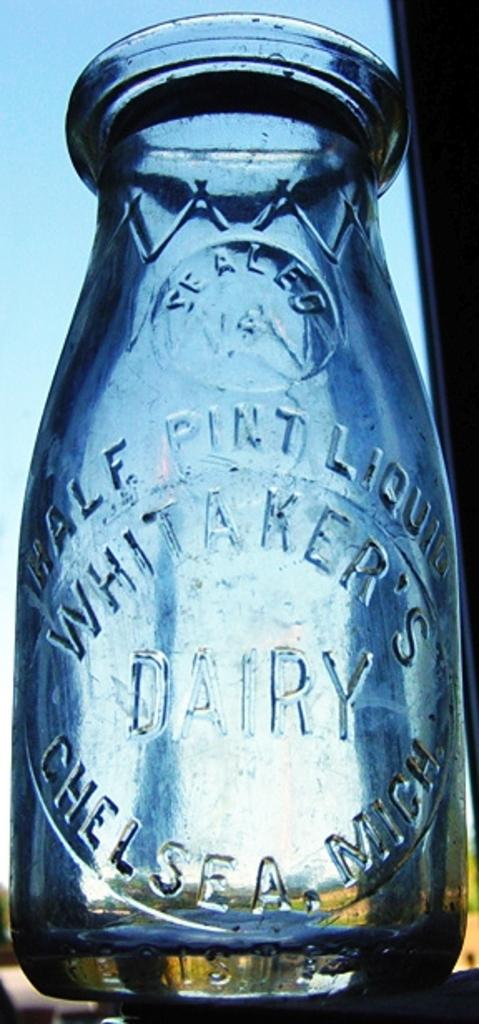<image>
Present a compact description of the photo's key features. An empty milk bottle bears the name of Whitaker's Dairy. 